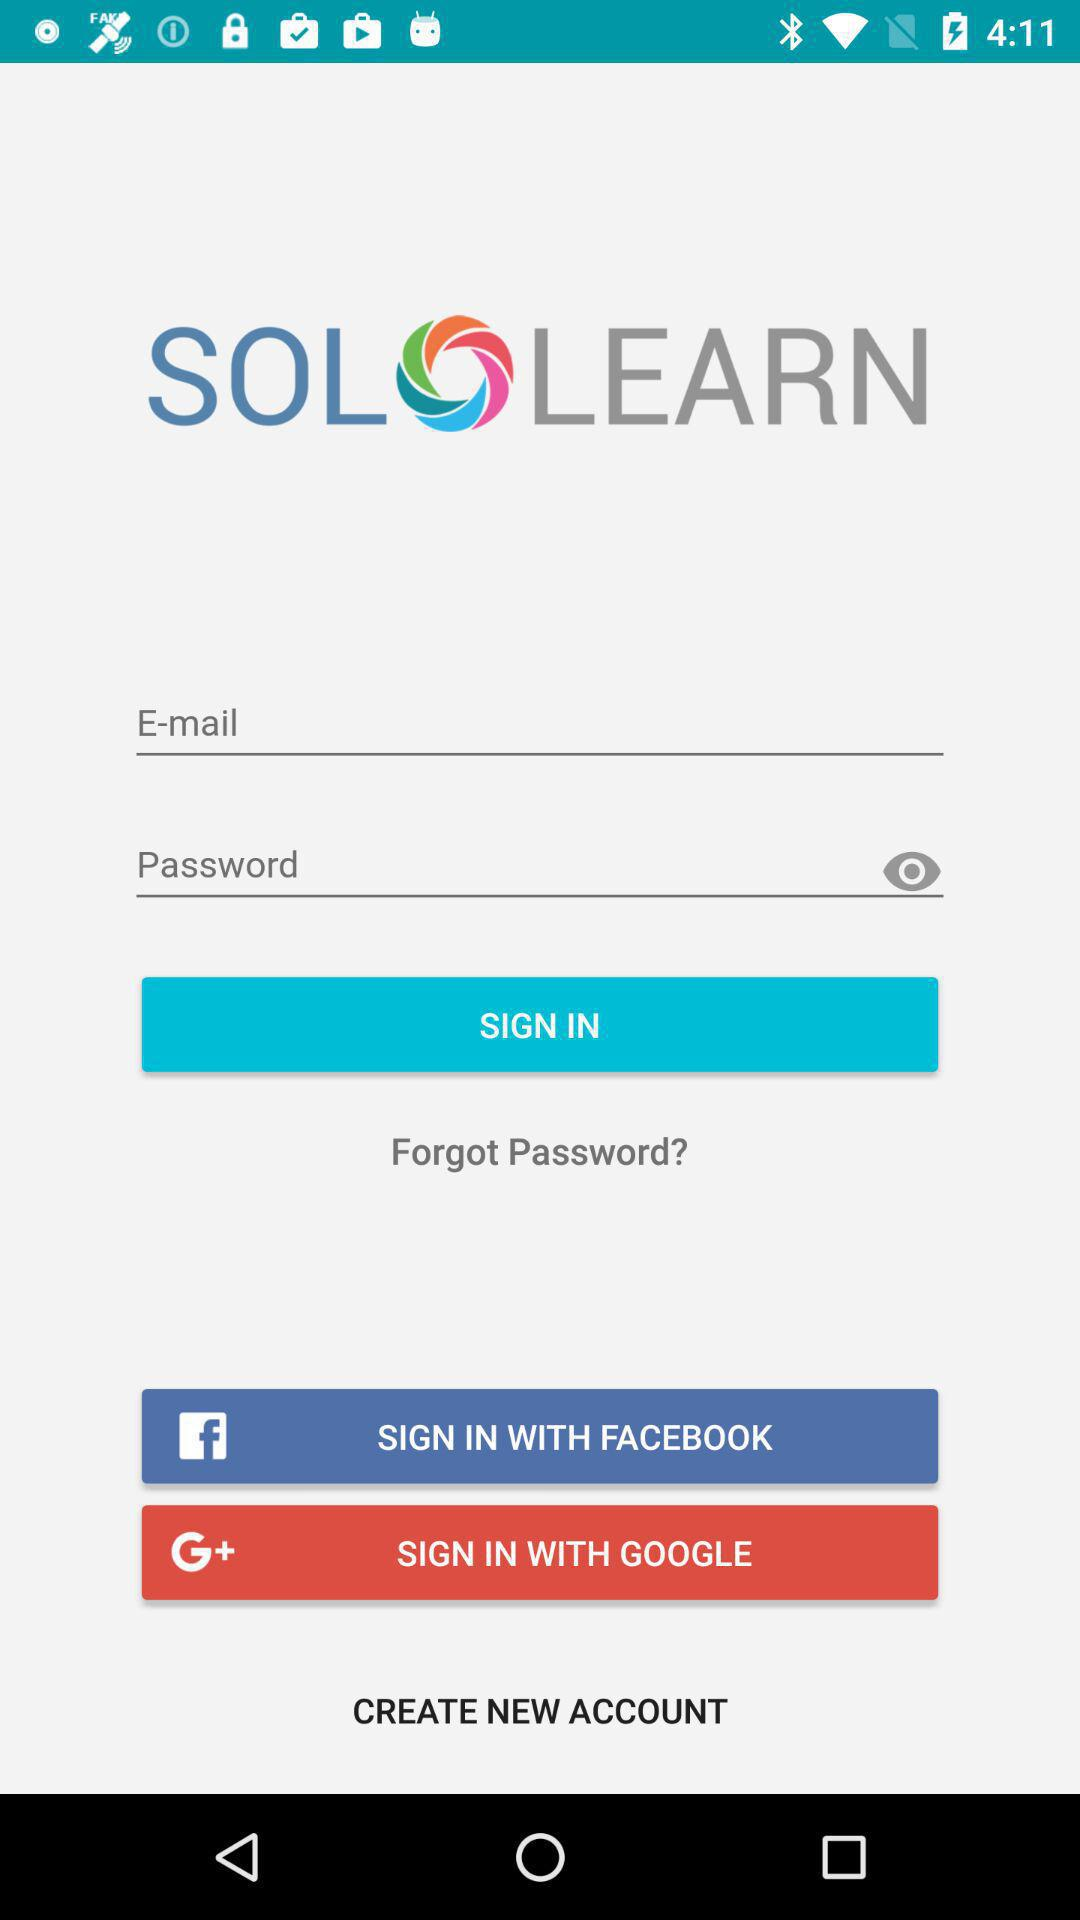What are the different options available to sign in? The different options available to sign in are "E-mail", "FACEBOOK" and "GOOGLE". 